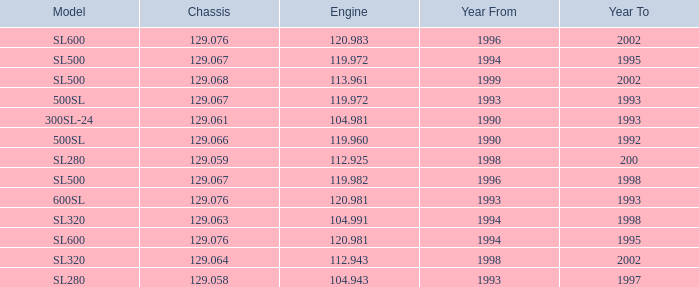Which Engine has a Model of sl500, and a Chassis smaller than 129.067? None. 